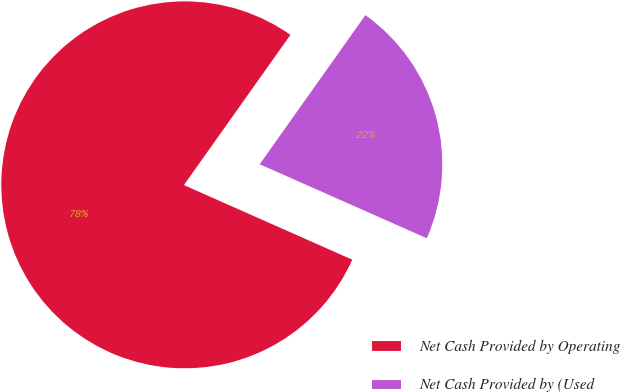Convert chart. <chart><loc_0><loc_0><loc_500><loc_500><pie_chart><fcel>Net Cash Provided by Operating<fcel>Net Cash Provided by (Used<nl><fcel>78.18%<fcel>21.82%<nl></chart> 